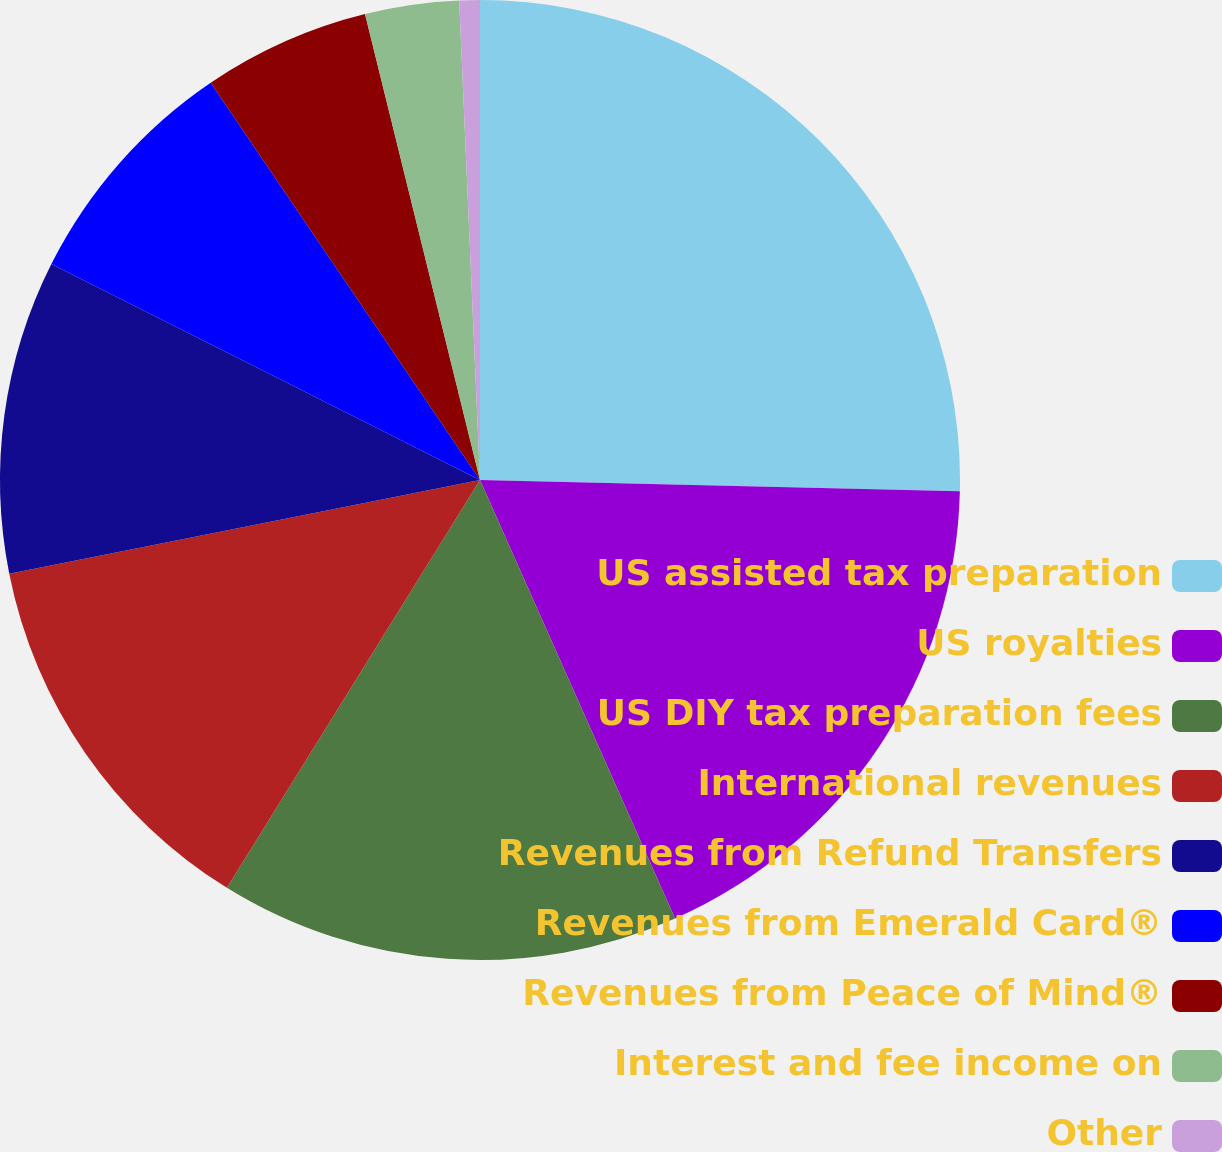Convert chart to OTSL. <chart><loc_0><loc_0><loc_500><loc_500><pie_chart><fcel>US assisted tax preparation<fcel>US royalties<fcel>US DIY tax preparation fees<fcel>International revenues<fcel>Revenues from Refund Transfers<fcel>Revenues from Emerald Card®<fcel>Revenues from Peace of Mind®<fcel>Interest and fee income on<fcel>Other<nl><fcel>25.37%<fcel>17.97%<fcel>15.5%<fcel>13.03%<fcel>10.56%<fcel>8.09%<fcel>5.63%<fcel>3.16%<fcel>0.69%<nl></chart> 